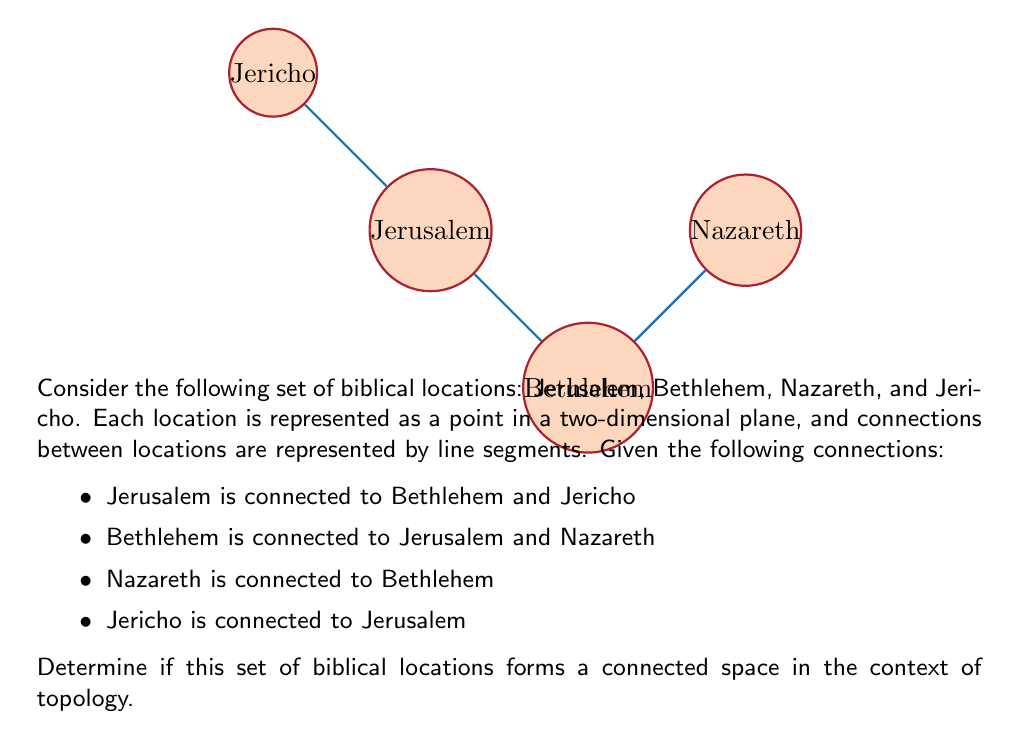Provide a solution to this math problem. To determine if the set of biblical locations forms a connected space, we need to check if there exists a path between any two locations in the set. Let's approach this step-by-step:

1. Definition: A topological space is connected if it cannot be represented as the union of two or more disjoint non-empty open sets.

2. In our context, this means that there should be a path between any two locations, either directly or through other locations.

3. Let's analyze the connections:
   - Jerusalem is directly connected to Bethlehem and Jericho.
   - Bethlehem is directly connected to Jerusalem and Nazareth.
   - Nazareth is directly connected to Bethlehem.
   - Jericho is directly connected to Jerusalem.

4. Now, let's check if we can reach every location from any starting point:
   - From Jerusalem: 
     * To Bethlehem: direct connection
     * To Nazareth: Jerusalem → Bethlehem → Nazareth
     * To Jericho: direct connection
   - From Bethlehem:
     * To Jerusalem: direct connection
     * To Nazareth: direct connection
     * To Jericho: Bethlehem → Jerusalem → Jericho
   - From Nazareth:
     * To Bethlehem: direct connection
     * To Jerusalem: Nazareth → Bethlehem → Jerusalem
     * To Jericho: Nazareth → Bethlehem → Jerusalem → Jericho
   - From Jericho:
     * To Jerusalem: direct connection
     * To Bethlehem: Jericho → Jerusalem → Bethlehem
     * To Nazareth: Jericho → Jerusalem → Bethlehem → Nazareth

5. We can see that there exists a path between any two locations in the set, either directly or through other locations.

6. Therefore, this set of biblical locations forms a connected space in the context of topology.
Answer: Yes, the space is connected. 